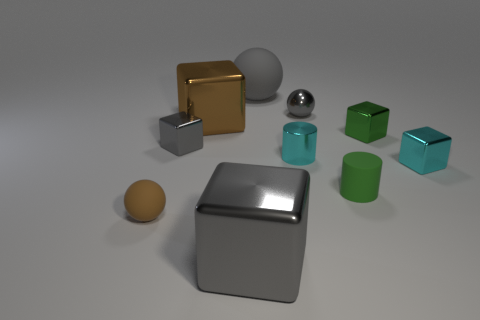Subtract all green metal blocks. How many blocks are left? 4 Subtract 2 blocks. How many blocks are left? 3 Subtract all brown cubes. How many cubes are left? 4 Subtract all red balls. Subtract all yellow cylinders. How many balls are left? 3 Subtract all cylinders. How many objects are left? 8 Add 1 large brown things. How many large brown things exist? 2 Subtract 0 blue balls. How many objects are left? 10 Subtract all matte cylinders. Subtract all tiny spheres. How many objects are left? 7 Add 3 tiny cylinders. How many tiny cylinders are left? 5 